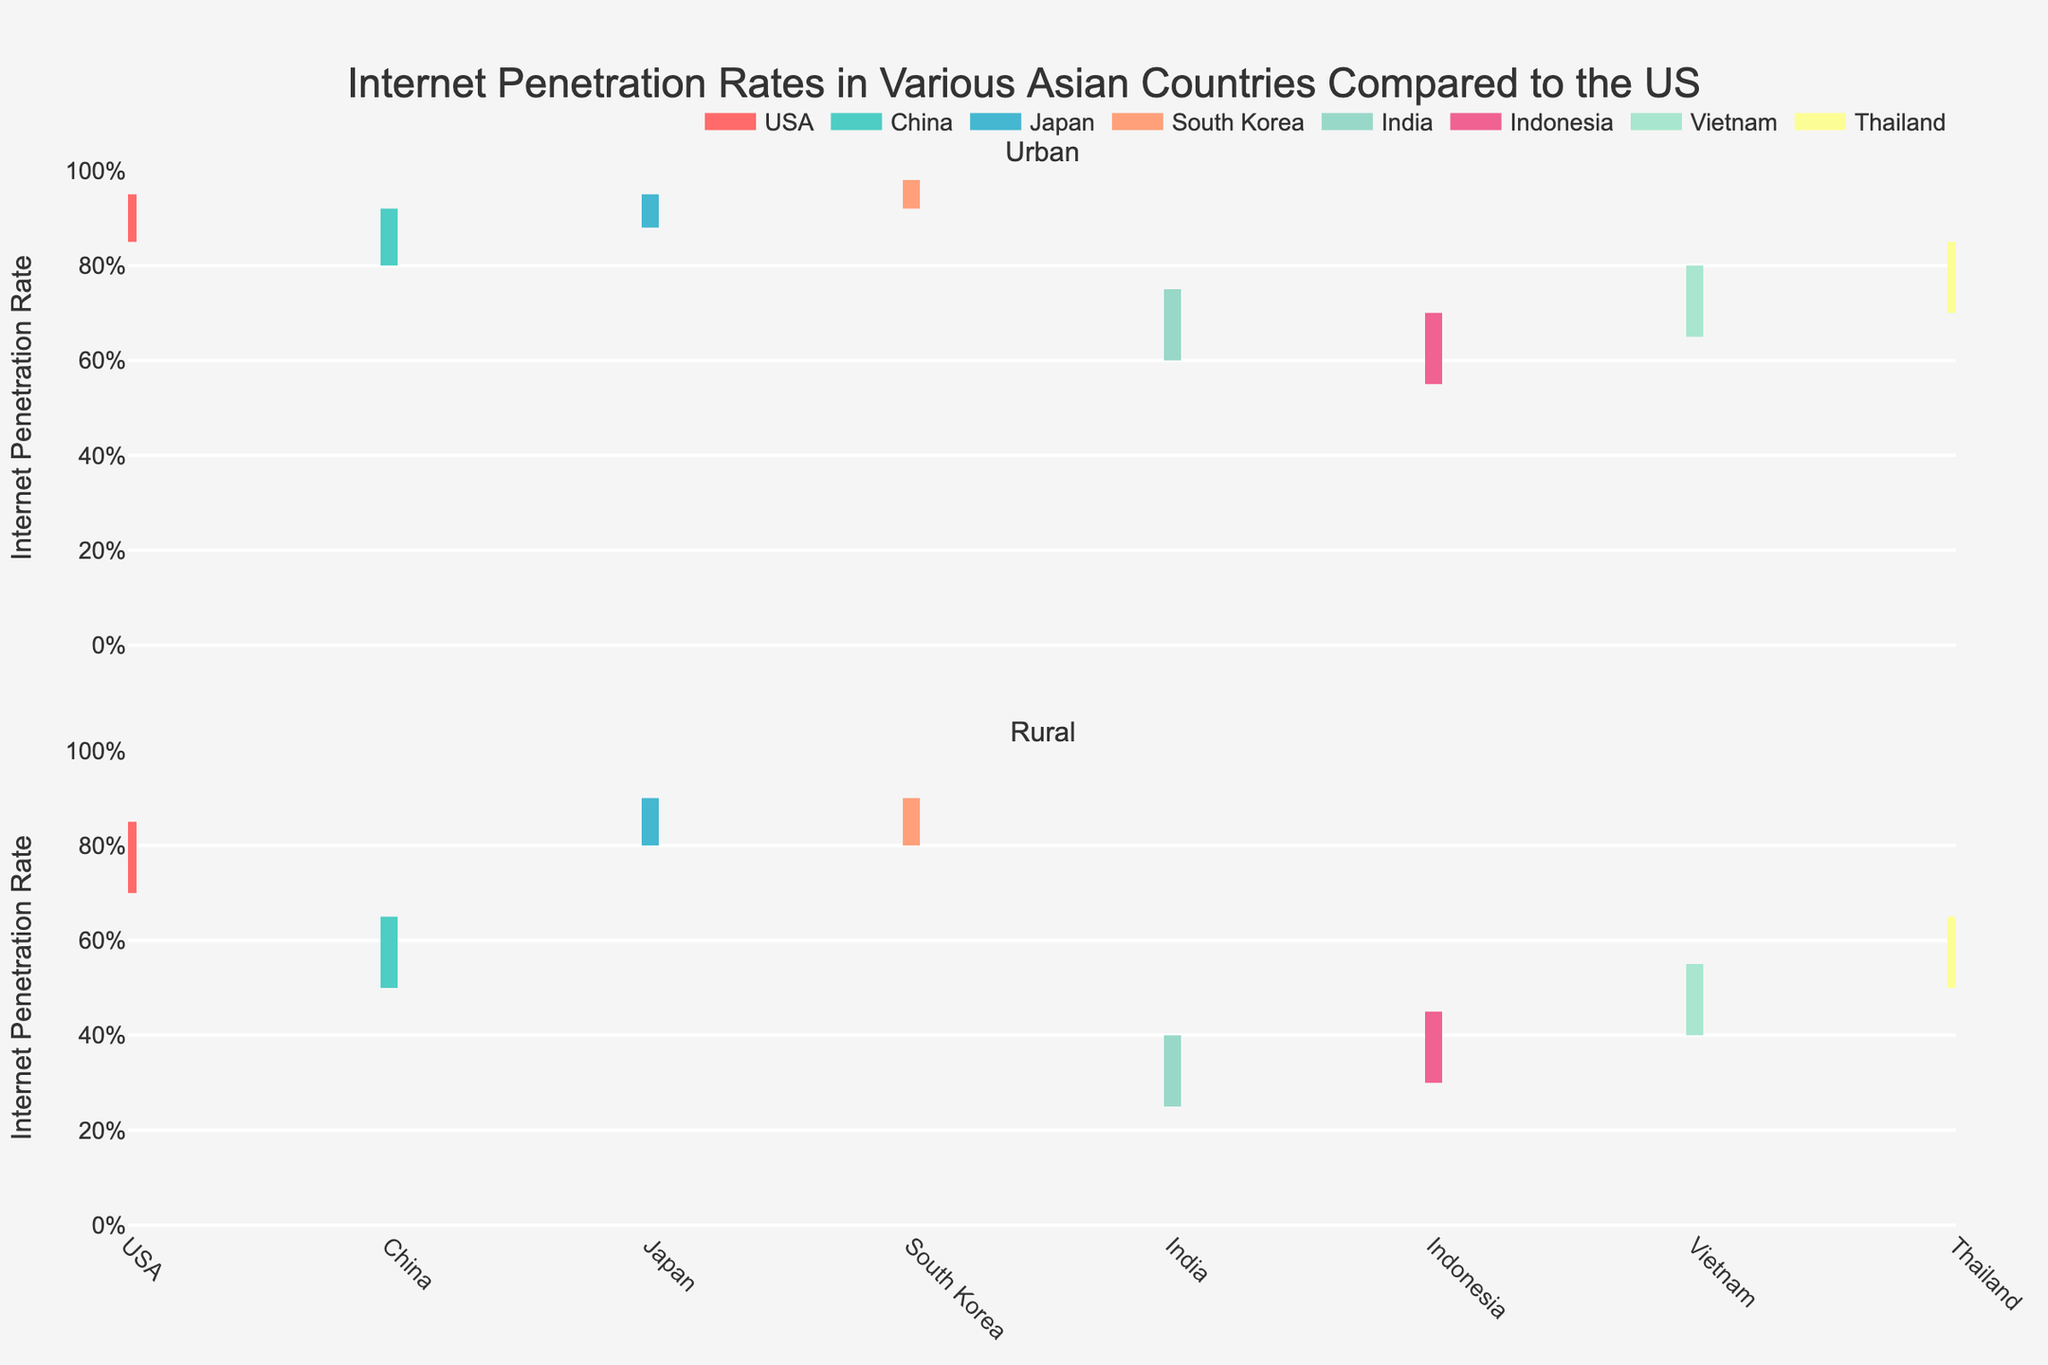What's the title of the chart? The title of a chart is typically found at the top center of the plot area. In this case, it clearly reads "Internet Penetration Rates in Various Asian Countries Compared to the US."
Answer: Internet Penetration Rates in Various Asian Countries Compared to the US What is the range of internet penetration in urban China? To find the range of internet penetration, you look at the values from the minimum to the maximum for urban China. The plot shows a line extending from 80.0% to 92.0%.
Answer: 80.0% to 92.0% Which country has the highest minimum internet penetration rate in rural areas and what is that rate? By assessing the rural population segments, we see that Japan and South Korea both have high minimum values. Japan and South Korea have rural penetration rates starting at 80.0%. Thus, the highest minimum is tied at 80.0%.
Answer: Japan and South Korea, 80.0% What is the difference between the maximum internet penetration rates in urban USA and rural USA? The difference between the maximum rates can be calculated by subtracting the rural maximum (85.0%) from the urban maximum (95.0%).
Answer: 95.0% - 85.0% = 10.0% Compare the average internet penetration rates of urban and rural South Korea. Is the urban rate higher? To compare averages, first calculate them for each population type in South Korea: (92.0% + 98.0%) / 2 = 95.0% for urban, and (80.0% + 90.0%) / 2 = 85.0% for rural. The urban rate is higher (95.0% vs. 85.0%).
Answer: Yes, urban rate is higher What is the internet penetration range for rural India and how does it compare to rural China? The range for rural India is 25.0% to 40.0%. For rural China, it is 50.0% to 65.0%. Comparing these, China's rural internet rate range is considerably higher than India's.
Answer: India's range: 25.0% to 40.0%, China's range: 50.0% to 65.0% Which country has the smallest gap between their urban and rural internet penetration rates and what is that gap? To find this, we calculate the difference for each country. The smallest gap is found by subtracting the maximum rural rate from the minimum urban rate within the same country. For Japan, it's minimal with an 8.0% gap (88.0% - 80.0%).
Answer: Japan, 8.0% What is the maximum internet penetration rate observed across all urban populations? We look for the highest peak among the urban ranges. South Korea's urban population has the highest maximum rate at 98.0%.
Answer: 98.0% Which country's rural population has the broadest range of internet penetration rates? The broadest range is calculated by subtracting the minimum penetration from the maximum. For India's rural population, it ranges from 25.0% to 40.0%, which is 15.0%, the broadest compared to other countries.
Answer: India, 15.0% Between Vietnam and Thailand, which country has a higher maximum internet penetration in both urban and rural areas? Comparing the highest rates for both urban and rural areas, for Vietnam: Urban 80.0%, Rural 55.0%. For Thailand: Urban 85.0%, Rural 65.0%. Thailand has higher maximum rates in both segments.
Answer: Thailand 